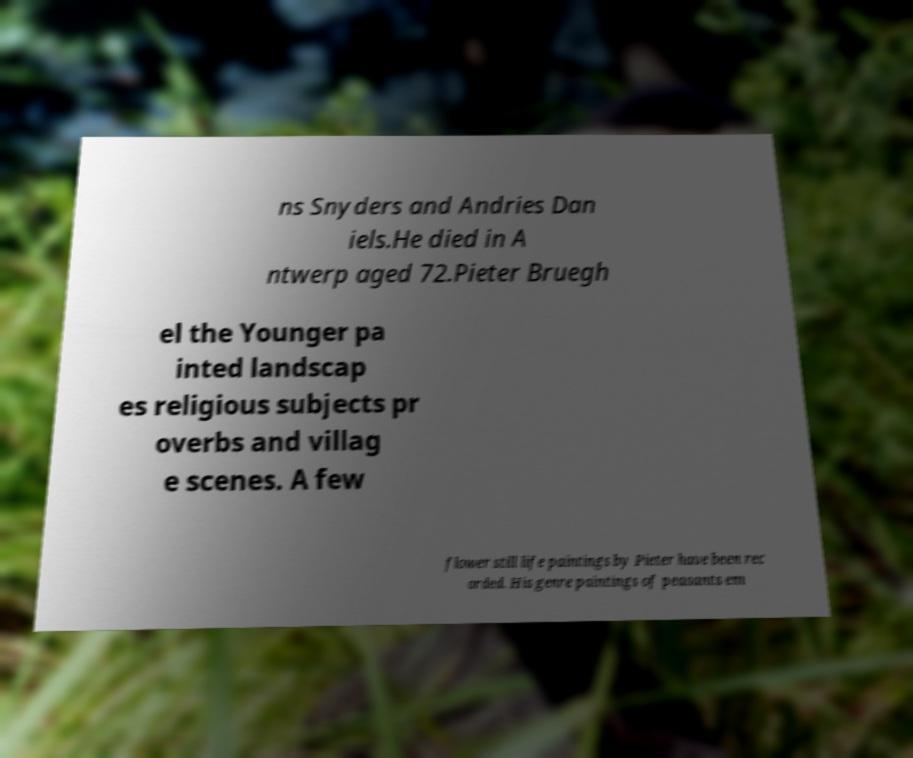Can you accurately transcribe the text from the provided image for me? ns Snyders and Andries Dan iels.He died in A ntwerp aged 72.Pieter Bruegh el the Younger pa inted landscap es religious subjects pr overbs and villag e scenes. A few flower still life paintings by Pieter have been rec orded. His genre paintings of peasants em 